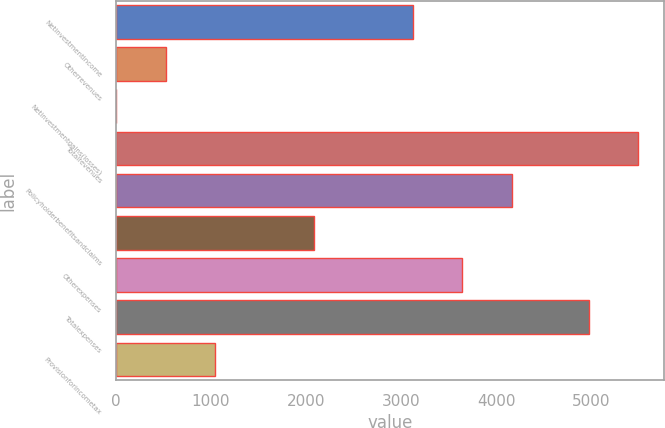Convert chart to OTSL. <chart><loc_0><loc_0><loc_500><loc_500><bar_chart><fcel>Netinvestmentincome<fcel>Otherrevenues<fcel>Netinvestmentgains(losses)<fcel>Totalrevenues<fcel>Policyholderbenefitsandclaims<fcel>Unnamed: 5<fcel>Otherexpenses<fcel>Totalexpenses<fcel>Provisionforincometax<nl><fcel>3124<fcel>526.5<fcel>7<fcel>5490.5<fcel>4163<fcel>2085<fcel>3643.5<fcel>4971<fcel>1046<nl></chart> 